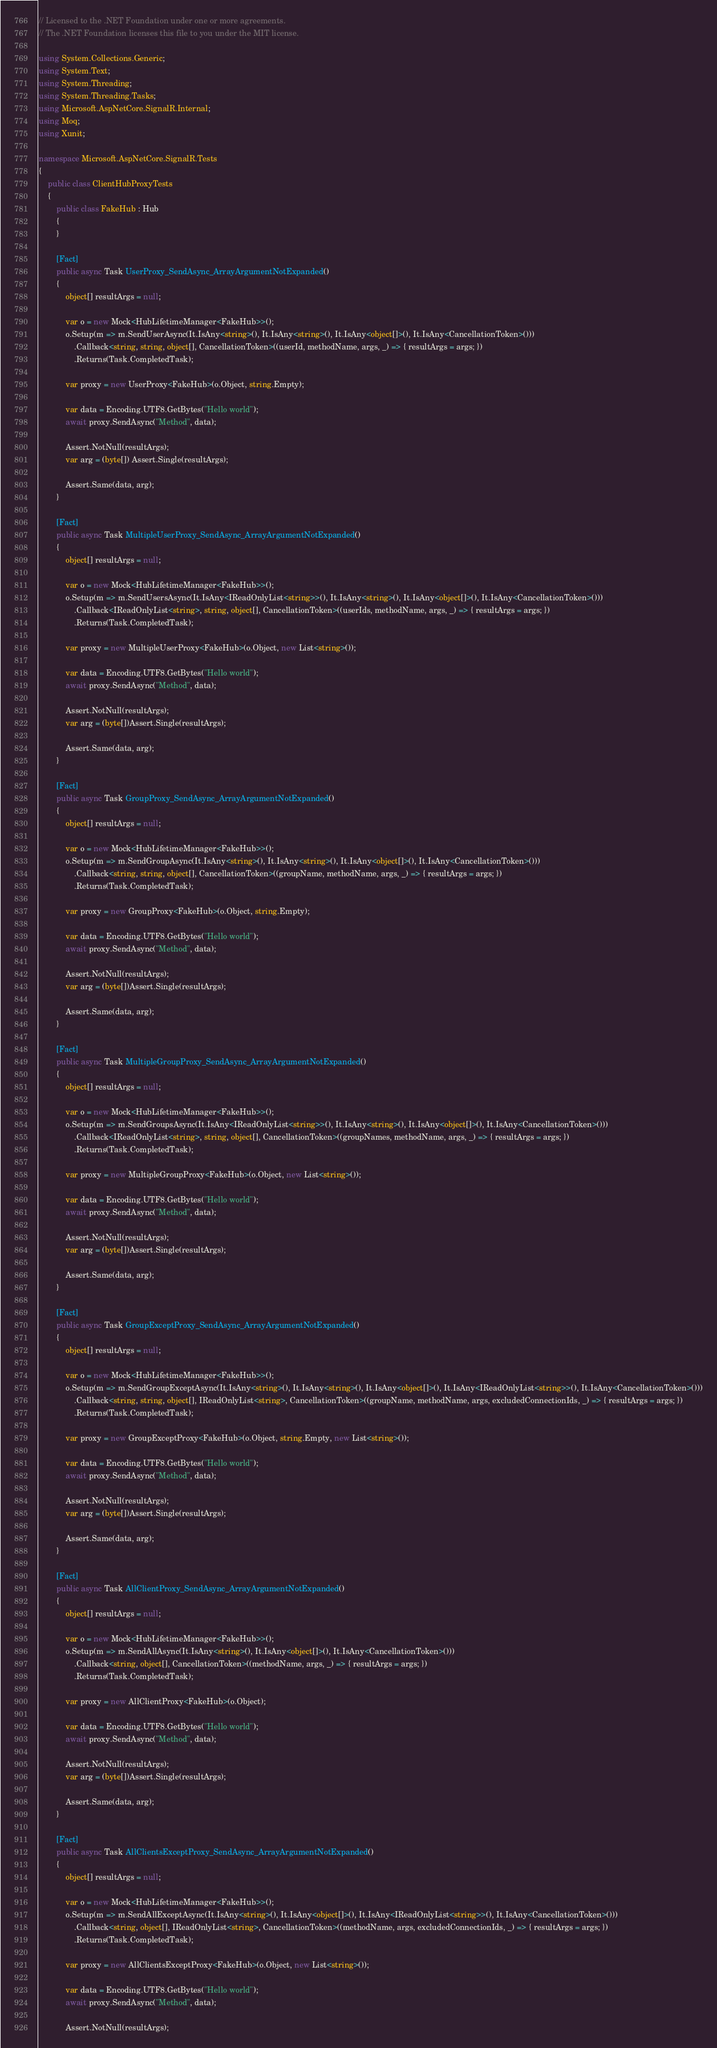<code> <loc_0><loc_0><loc_500><loc_500><_C#_>// Licensed to the .NET Foundation under one or more agreements.
// The .NET Foundation licenses this file to you under the MIT license.

using System.Collections.Generic;
using System.Text;
using System.Threading;
using System.Threading.Tasks;
using Microsoft.AspNetCore.SignalR.Internal;
using Moq;
using Xunit;

namespace Microsoft.AspNetCore.SignalR.Tests
{
    public class ClientHubProxyTests
    {
        public class FakeHub : Hub
        {
        }

        [Fact]
        public async Task UserProxy_SendAsync_ArrayArgumentNotExpanded()
        {
            object[] resultArgs = null;

            var o = new Mock<HubLifetimeManager<FakeHub>>();
            o.Setup(m => m.SendUserAsync(It.IsAny<string>(), It.IsAny<string>(), It.IsAny<object[]>(), It.IsAny<CancellationToken>()))
                .Callback<string, string, object[], CancellationToken>((userId, methodName, args, _) => { resultArgs = args; })
                .Returns(Task.CompletedTask);

            var proxy = new UserProxy<FakeHub>(o.Object, string.Empty);

            var data = Encoding.UTF8.GetBytes("Hello world");
            await proxy.SendAsync("Method", data);

            Assert.NotNull(resultArgs);
            var arg = (byte[]) Assert.Single(resultArgs);

            Assert.Same(data, arg);
        }

        [Fact]
        public async Task MultipleUserProxy_SendAsync_ArrayArgumentNotExpanded()
        {
            object[] resultArgs = null;

            var o = new Mock<HubLifetimeManager<FakeHub>>();
            o.Setup(m => m.SendUsersAsync(It.IsAny<IReadOnlyList<string>>(), It.IsAny<string>(), It.IsAny<object[]>(), It.IsAny<CancellationToken>()))
                .Callback<IReadOnlyList<string>, string, object[], CancellationToken>((userIds, methodName, args, _) => { resultArgs = args; })
                .Returns(Task.CompletedTask);

            var proxy = new MultipleUserProxy<FakeHub>(o.Object, new List<string>());

            var data = Encoding.UTF8.GetBytes("Hello world");
            await proxy.SendAsync("Method", data);

            Assert.NotNull(resultArgs);
            var arg = (byte[])Assert.Single(resultArgs);

            Assert.Same(data, arg);
        }

        [Fact]
        public async Task GroupProxy_SendAsync_ArrayArgumentNotExpanded()
        {
            object[] resultArgs = null;

            var o = new Mock<HubLifetimeManager<FakeHub>>();
            o.Setup(m => m.SendGroupAsync(It.IsAny<string>(), It.IsAny<string>(), It.IsAny<object[]>(), It.IsAny<CancellationToken>()))
                .Callback<string, string, object[], CancellationToken>((groupName, methodName, args, _) => { resultArgs = args; })
                .Returns(Task.CompletedTask);

            var proxy = new GroupProxy<FakeHub>(o.Object, string.Empty);

            var data = Encoding.UTF8.GetBytes("Hello world");
            await proxy.SendAsync("Method", data);

            Assert.NotNull(resultArgs);
            var arg = (byte[])Assert.Single(resultArgs);

            Assert.Same(data, arg);
        }

        [Fact]
        public async Task MultipleGroupProxy_SendAsync_ArrayArgumentNotExpanded()
        {
            object[] resultArgs = null;

            var o = new Mock<HubLifetimeManager<FakeHub>>();
            o.Setup(m => m.SendGroupsAsync(It.IsAny<IReadOnlyList<string>>(), It.IsAny<string>(), It.IsAny<object[]>(), It.IsAny<CancellationToken>()))
                .Callback<IReadOnlyList<string>, string, object[], CancellationToken>((groupNames, methodName, args, _) => { resultArgs = args; })
                .Returns(Task.CompletedTask);

            var proxy = new MultipleGroupProxy<FakeHub>(o.Object, new List<string>());

            var data = Encoding.UTF8.GetBytes("Hello world");
            await proxy.SendAsync("Method", data);

            Assert.NotNull(resultArgs);
            var arg = (byte[])Assert.Single(resultArgs);

            Assert.Same(data, arg);
        }

        [Fact]
        public async Task GroupExceptProxy_SendAsync_ArrayArgumentNotExpanded()
        {
            object[] resultArgs = null;

            var o = new Mock<HubLifetimeManager<FakeHub>>();
            o.Setup(m => m.SendGroupExceptAsync(It.IsAny<string>(), It.IsAny<string>(), It.IsAny<object[]>(), It.IsAny<IReadOnlyList<string>>(), It.IsAny<CancellationToken>()))
                .Callback<string, string, object[], IReadOnlyList<string>, CancellationToken>((groupName, methodName, args, excludedConnectionIds, _) => { resultArgs = args; })
                .Returns(Task.CompletedTask);

            var proxy = new GroupExceptProxy<FakeHub>(o.Object, string.Empty, new List<string>());

            var data = Encoding.UTF8.GetBytes("Hello world");
            await proxy.SendAsync("Method", data);

            Assert.NotNull(resultArgs);
            var arg = (byte[])Assert.Single(resultArgs);

            Assert.Same(data, arg);
        }

        [Fact]
        public async Task AllClientProxy_SendAsync_ArrayArgumentNotExpanded()
        {
            object[] resultArgs = null;

            var o = new Mock<HubLifetimeManager<FakeHub>>();
            o.Setup(m => m.SendAllAsync(It.IsAny<string>(), It.IsAny<object[]>(), It.IsAny<CancellationToken>()))
                .Callback<string, object[], CancellationToken>((methodName, args, _) => { resultArgs = args; })
                .Returns(Task.CompletedTask);

            var proxy = new AllClientProxy<FakeHub>(o.Object);

            var data = Encoding.UTF8.GetBytes("Hello world");
            await proxy.SendAsync("Method", data);

            Assert.NotNull(resultArgs);
            var arg = (byte[])Assert.Single(resultArgs);

            Assert.Same(data, arg);
        }

        [Fact]
        public async Task AllClientsExceptProxy_SendAsync_ArrayArgumentNotExpanded()
        {
            object[] resultArgs = null;

            var o = new Mock<HubLifetimeManager<FakeHub>>();
            o.Setup(m => m.SendAllExceptAsync(It.IsAny<string>(), It.IsAny<object[]>(), It.IsAny<IReadOnlyList<string>>(), It.IsAny<CancellationToken>()))
                .Callback<string, object[], IReadOnlyList<string>, CancellationToken>((methodName, args, excludedConnectionIds, _) => { resultArgs = args; })
                .Returns(Task.CompletedTask);

            var proxy = new AllClientsExceptProxy<FakeHub>(o.Object, new List<string>());

            var data = Encoding.UTF8.GetBytes("Hello world");
            await proxy.SendAsync("Method", data);

            Assert.NotNull(resultArgs);</code> 